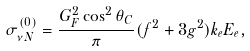<formula> <loc_0><loc_0><loc_500><loc_500>\sigma _ { \nu N } ^ { ( 0 ) } = \frac { G _ { F } ^ { 2 } \cos ^ { 2 } \theta _ { C } } { \pi } ( f ^ { 2 } + 3 g ^ { 2 } ) k _ { e } E _ { e } ,</formula> 